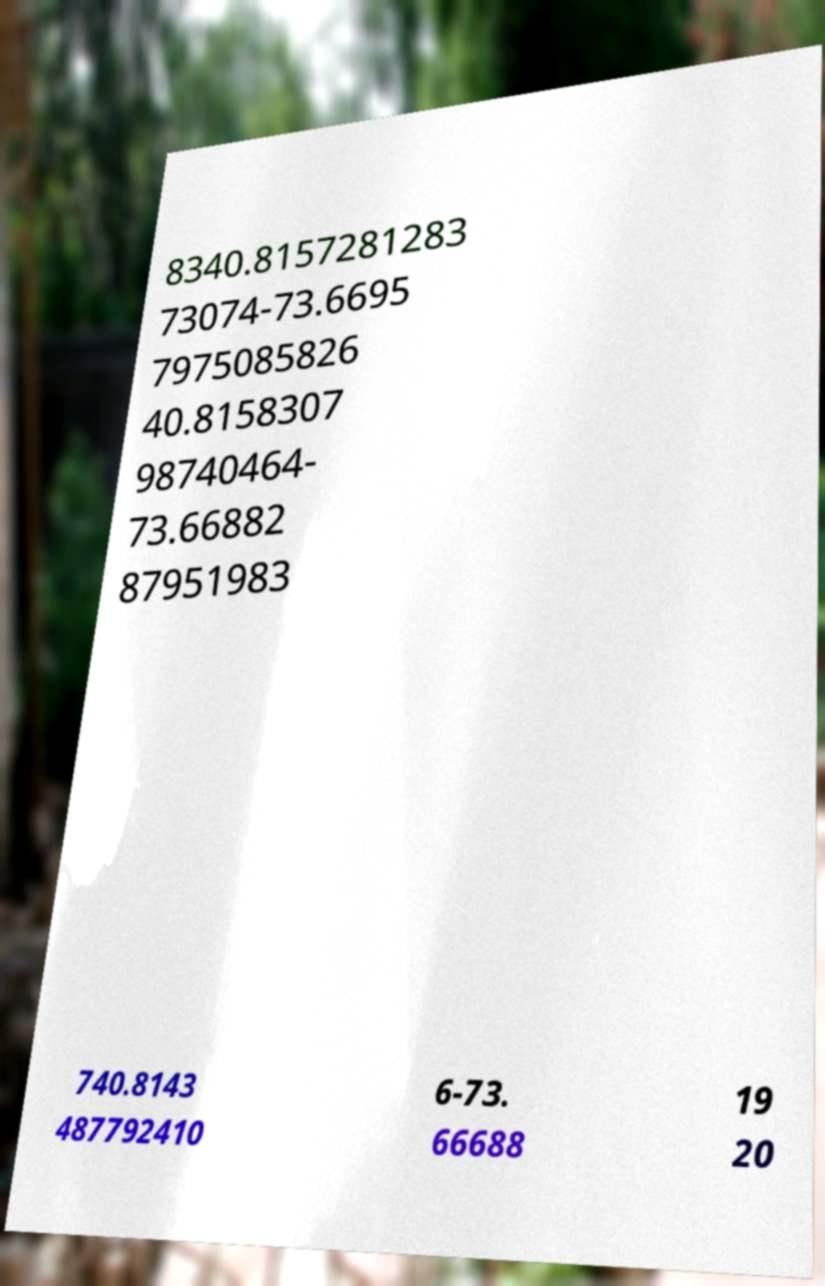For documentation purposes, I need the text within this image transcribed. Could you provide that? 8340.8157281283 73074-73.6695 7975085826 40.8158307 98740464- 73.66882 87951983 740.8143 487792410 6-73. 66688 19 20 